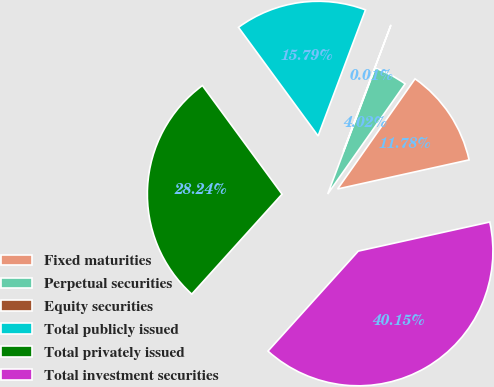Convert chart to OTSL. <chart><loc_0><loc_0><loc_500><loc_500><pie_chart><fcel>Fixed maturities<fcel>Perpetual securities<fcel>Equity securities<fcel>Total publicly issued<fcel>Total privately issued<fcel>Total investment securities<nl><fcel>11.78%<fcel>4.02%<fcel>0.01%<fcel>15.79%<fcel>28.24%<fcel>40.15%<nl></chart> 